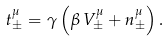Convert formula to latex. <formula><loc_0><loc_0><loc_500><loc_500>t _ { \pm } ^ { \mu } = \gamma \left ( \beta \, V _ { \pm } ^ { \mu } + n _ { \pm } ^ { \mu } \right ) .</formula> 